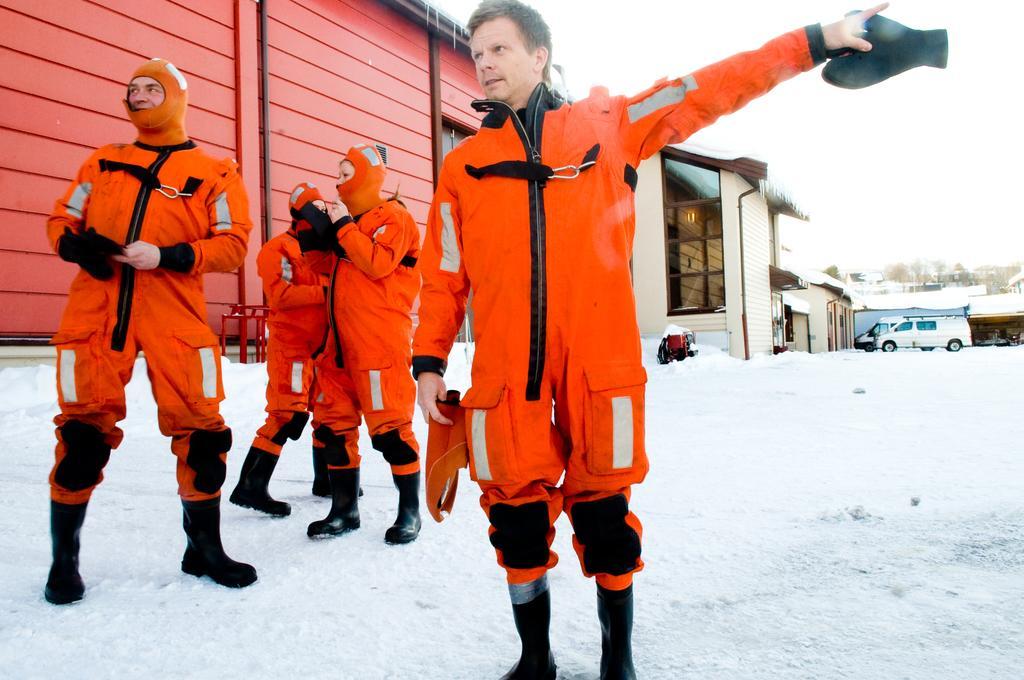How would you summarize this image in a sentence or two? In front of the image there is a person standing by holding gloves in his hand, behind him there are a few other people, behind them there are houses with glass windows and there are cars, in the background of the image there are trees and there is snow on the surface. 